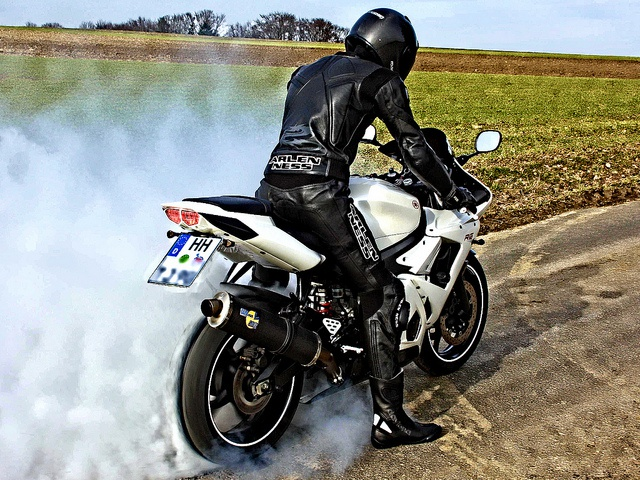Describe the objects in this image and their specific colors. I can see motorcycle in lightblue, black, white, gray, and darkgray tones and people in lightblue, black, gray, and darkgray tones in this image. 